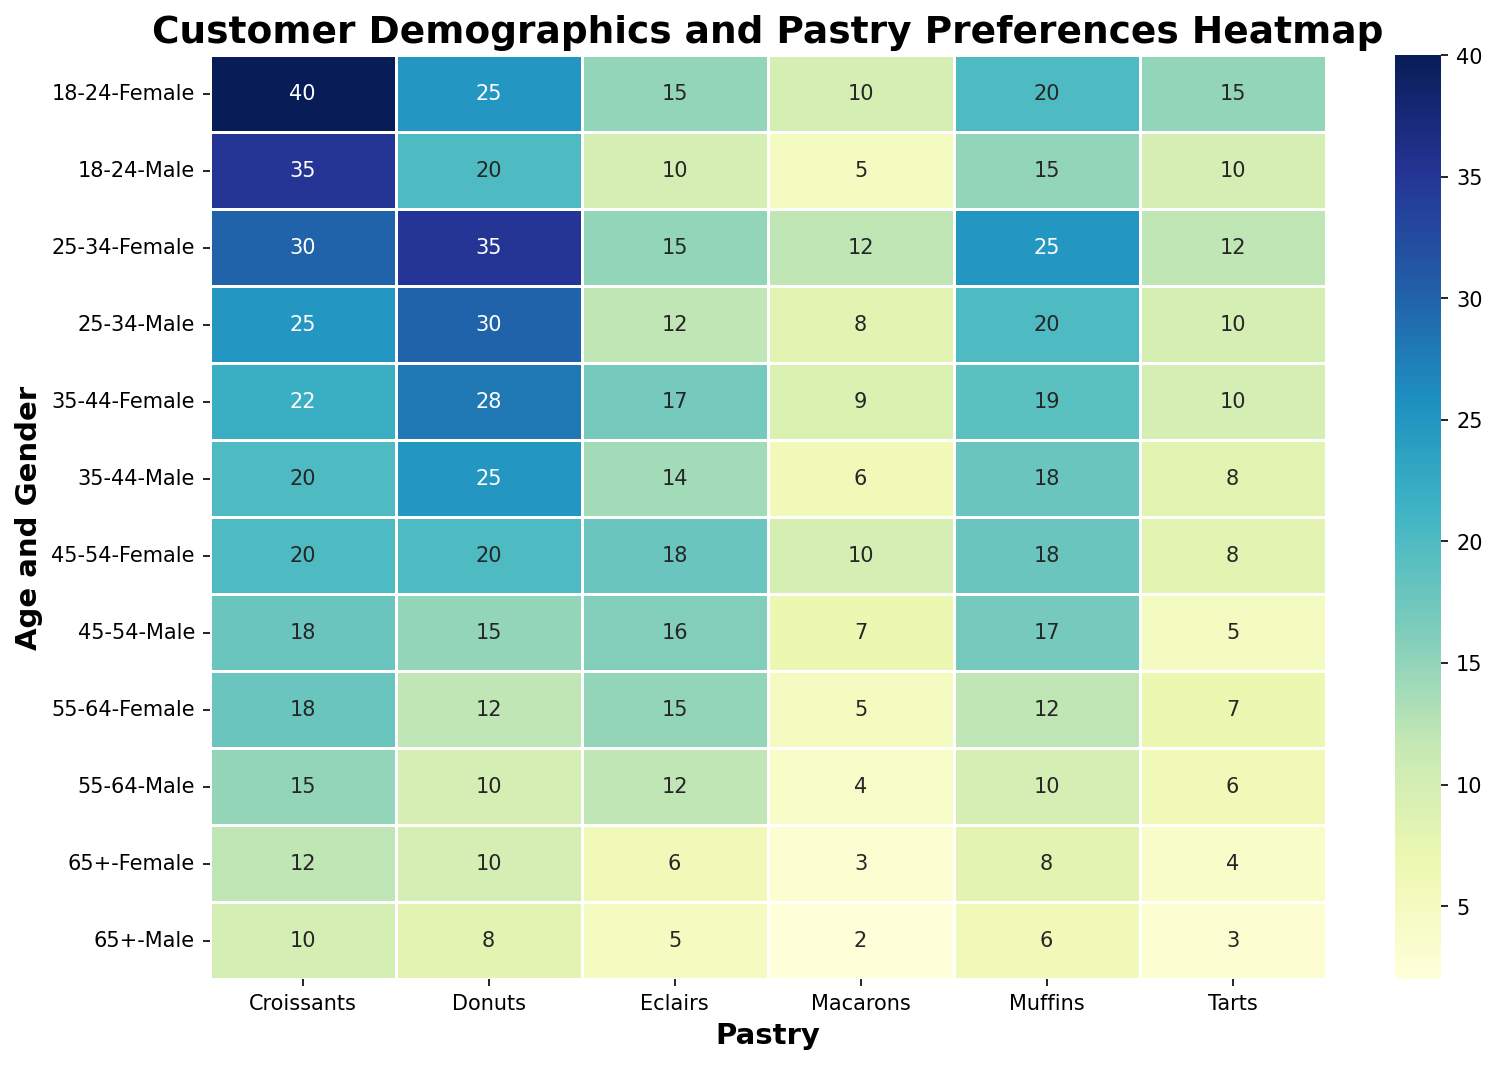What age and gender group prefers croissants the most? Look for the highest value in the Croissants column. The highest count is 40 in the '18-24' age group for females.
Answer: 18-24 Female Which pastry is the least liked by males aged 25-34? Locate the row for males aged 25-34 and find the smallest number. The smallest value is 8 for Macarons.
Answer: Macarons What is the total preference count for Muffins by females across all age groups? Sum the Muffins column values for females. The sum is 20 + 25 + 19 + 18 + 12 + 8 = 102.
Answer: 102 Compare the preference for Donuts between females in the '18-24' and '25-34' age groups. Which group prefers it more? Check the Donuts values for both groups. The '18-24' females have a count of 25 and the '25-34' females have a count of 35. Since 35 is greater than 25, the '25-34' group prefers it more.
Answer: 25-34 Among males aged 35-44, which two pastries have almost the same preference count, and what are those counts? Look for nearly identical values in the row for males aged 35-44. The values for Eclairs and Muffins are both close, with Eclairs at 14 and Muffins at 18.
Answer: Eclairs (14) and Muffins (18) What's the average number of Tarts preferred by customers aged 45-54? Calculate the average of Tarts preferences in this age group. (5 + 8) / 2 = 6.5.
Answer: 6.5 Which gender in the '55-64' age group has a higher preference for Eclairs, and by how much? Compare Eclairs values in males (12) and females (15). The difference is 3, with females preferring it more.
Answer: Female, by 3 Which pastry has the overall highest preference count among all categories? Find the highest value across all the cells. The highest value is 40 for Croissants in the '18-24' female category.
Answer: Croissants By how much do preferences for Muffins in females aged 35-44 exceed those in males aged 35-44? Subtract the Muffins preference for males aged 35-44 (18) from females aged 35-44 (19). The result is 1.
Answer: 1 Is there any age and gender group where the preference for Eclairs is higher than 15? List them. Check the Eclairs column for values greater than 15. Females aged '45-54' have a preference of 18.
Answer: 45-54 Female 